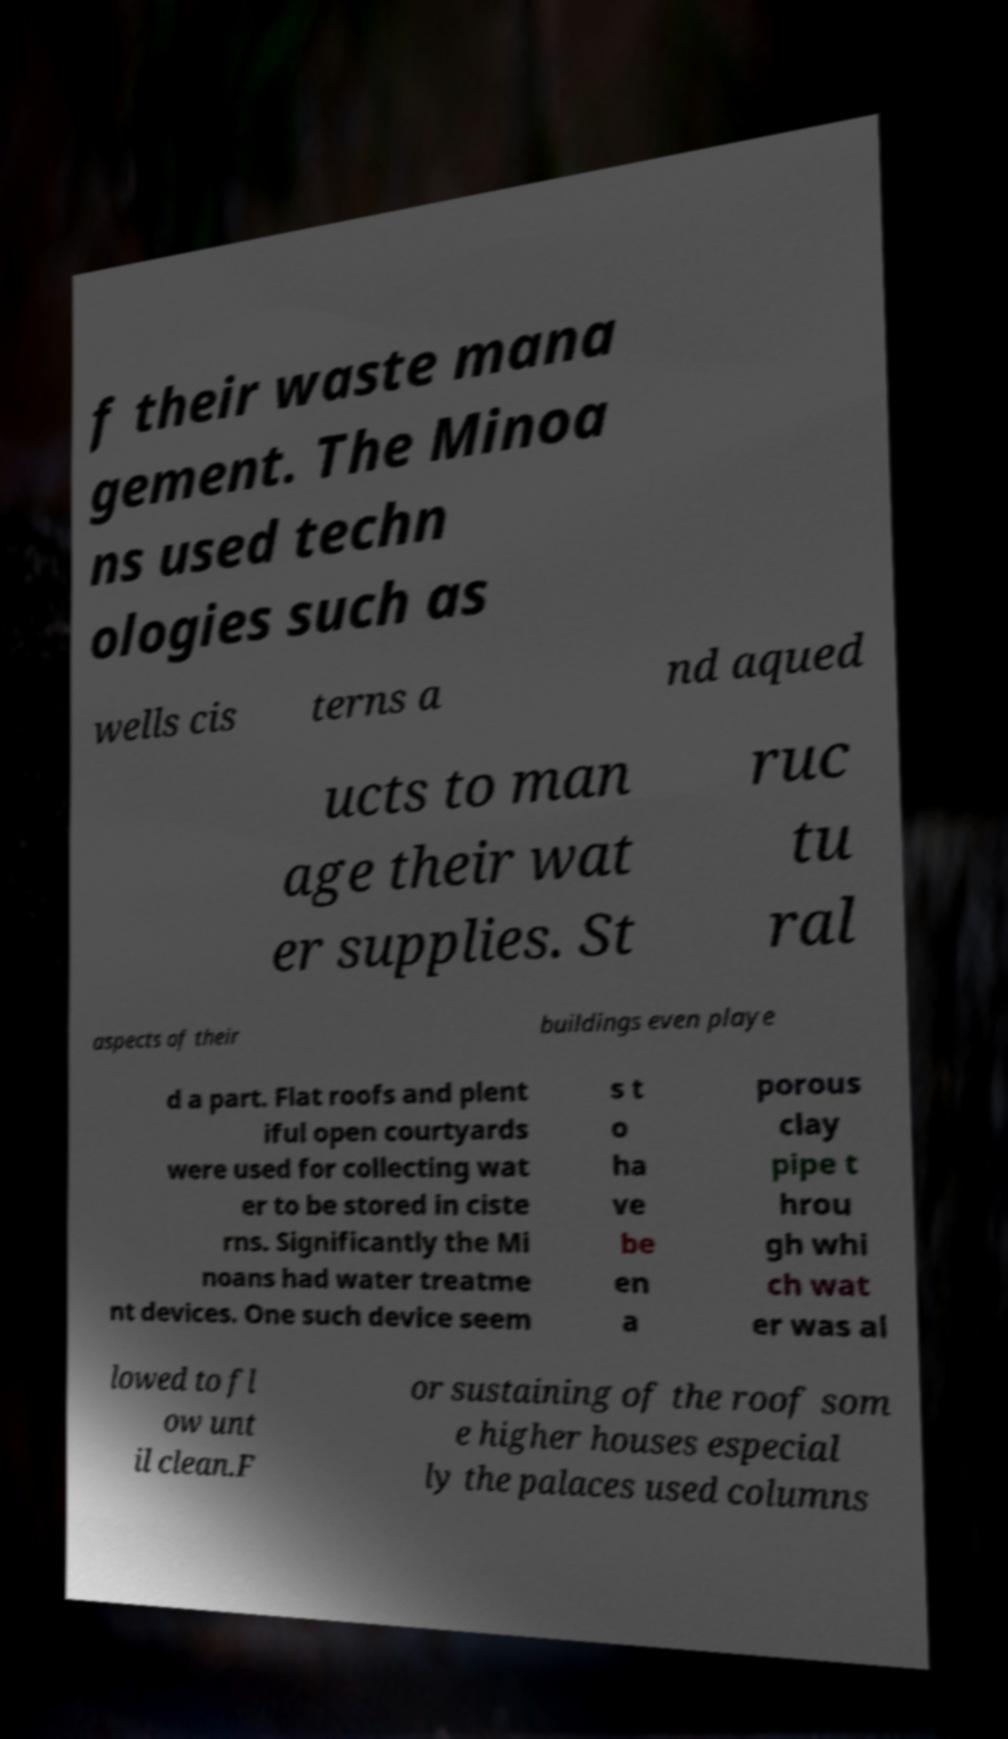Can you accurately transcribe the text from the provided image for me? f their waste mana gement. The Minoa ns used techn ologies such as wells cis terns a nd aqued ucts to man age their wat er supplies. St ruc tu ral aspects of their buildings even playe d a part. Flat roofs and plent iful open courtyards were used for collecting wat er to be stored in ciste rns. Significantly the Mi noans had water treatme nt devices. One such device seem s t o ha ve be en a porous clay pipe t hrou gh whi ch wat er was al lowed to fl ow unt il clean.F or sustaining of the roof som e higher houses especial ly the palaces used columns 